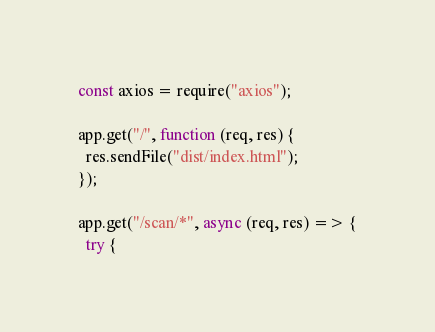<code> <loc_0><loc_0><loc_500><loc_500><_JavaScript_>const axios = require("axios");

app.get("/", function (req, res) {
  res.sendFile("dist/index.html");
});

app.get("/scan/*", async (req, res) => {
  try {</code> 